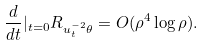Convert formula to latex. <formula><loc_0><loc_0><loc_500><loc_500>\frac { d } { d t } | _ { t = 0 } R _ { u _ { t } ^ { - 2 } \theta } = O ( \rho ^ { 4 } \log \rho ) .</formula> 